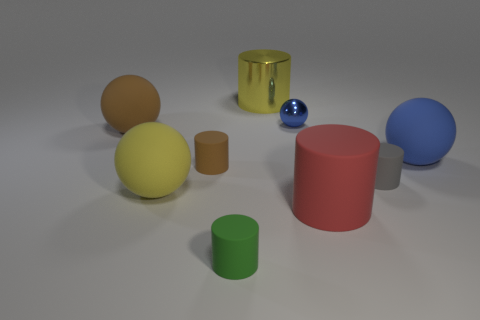Subtract all green cylinders. How many cylinders are left? 4 Subtract all purple cylinders. Subtract all purple balls. How many cylinders are left? 5 Add 1 large metallic cylinders. How many objects exist? 10 Subtract all cylinders. How many objects are left? 4 Subtract 0 purple cubes. How many objects are left? 9 Subtract all blue objects. Subtract all large matte cylinders. How many objects are left? 6 Add 3 blue matte objects. How many blue matte objects are left? 4 Add 5 small gray rubber spheres. How many small gray rubber spheres exist? 5 